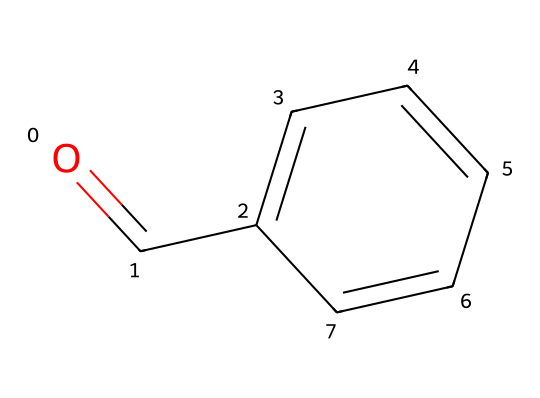What is the molecular formula of benzaldehyde? The molecular formula can be derived from the visual representation of the chemical structure. In the structure, we see one carbonyl group (C=O) and a phenyl ring (C6H5), which together result in the formula C7H6O.
Answer: C7H6O How many carbon atoms are in benzaldehyde? By analyzing the structure, benzaldehyde contains a total of seven carbon atoms: one in the carbonyl group and six in the aromatic ring.
Answer: 7 What functional group is present in benzaldehyde? The presence of the carbonyl group (C=O) defines benzaldehyde as an aldehyde, which is characterized by having a carbonyl group attached to a carbon atom of a hydrogen atom.
Answer: aldehyde What type of compound is benzaldehyde? Benzaldehyde is classified as an aromatic aldehyde due to the presence of an aromatic ring (phenyl) and a carbonyl group.
Answer: aromatic aldehyde How many hydrogen atoms are present in benzaldehyde? The structure shows that there are six hydrogen atoms associated with the benzene ring, and one hydrogen is part of the aldehyde functional group, leading to a total of six hydrogen atoms.
Answer: 6 Is benzaldehyde polar or nonpolar? The carbonyl group contributes to the polarity of the molecule, while the aromatic ring is relatively nonpolar. Therefore, the overall molecule is considered polar due to the presence of the carbonyl group.
Answer: polar What is the boiling point of benzaldehyde? Benzaldehyde has a known boiling point of approximately 178 degrees Celsius, which can be referenced in chemical databases or literature related to its physical properties.
Answer: 178 degrees Celsius 